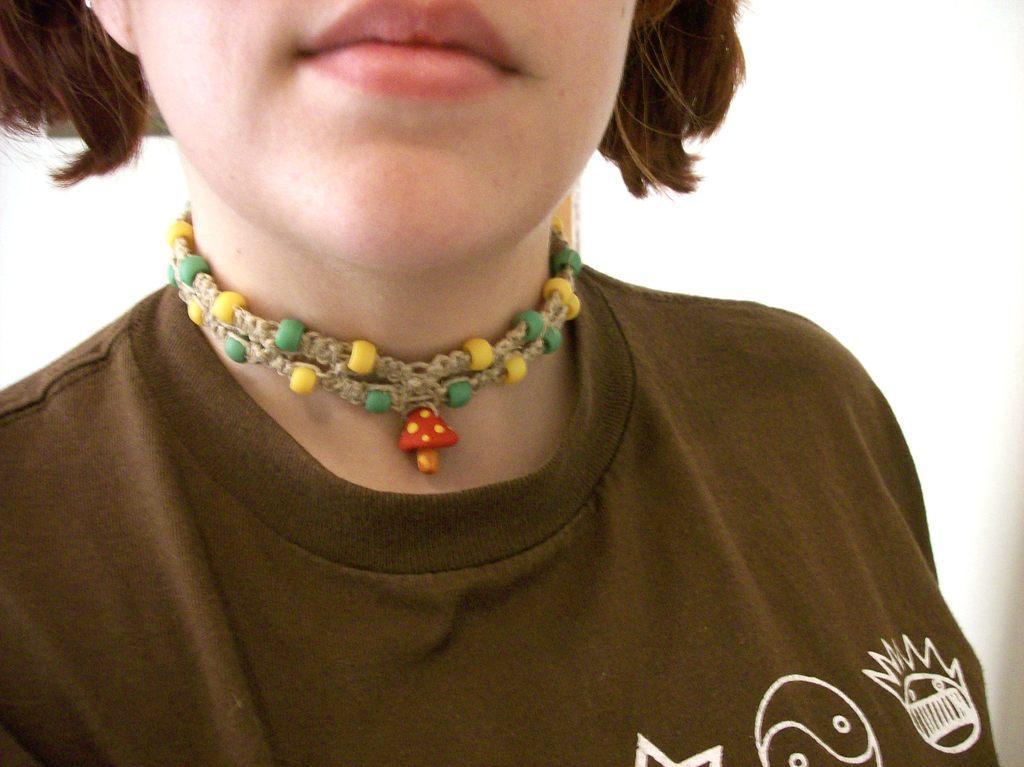How would you summarize this image in a sentence or two? In this image we can see there is a person, behind her there is a wall. 